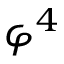<formula> <loc_0><loc_0><loc_500><loc_500>\varphi ^ { 4 }</formula> 